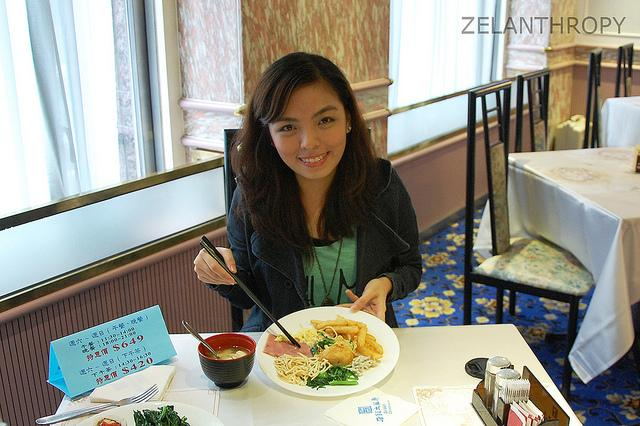Which city is most likely serving this restaurant?

Choices:
A) shanghai
B) singapore
C) hong kong
D) beijing hong kong 